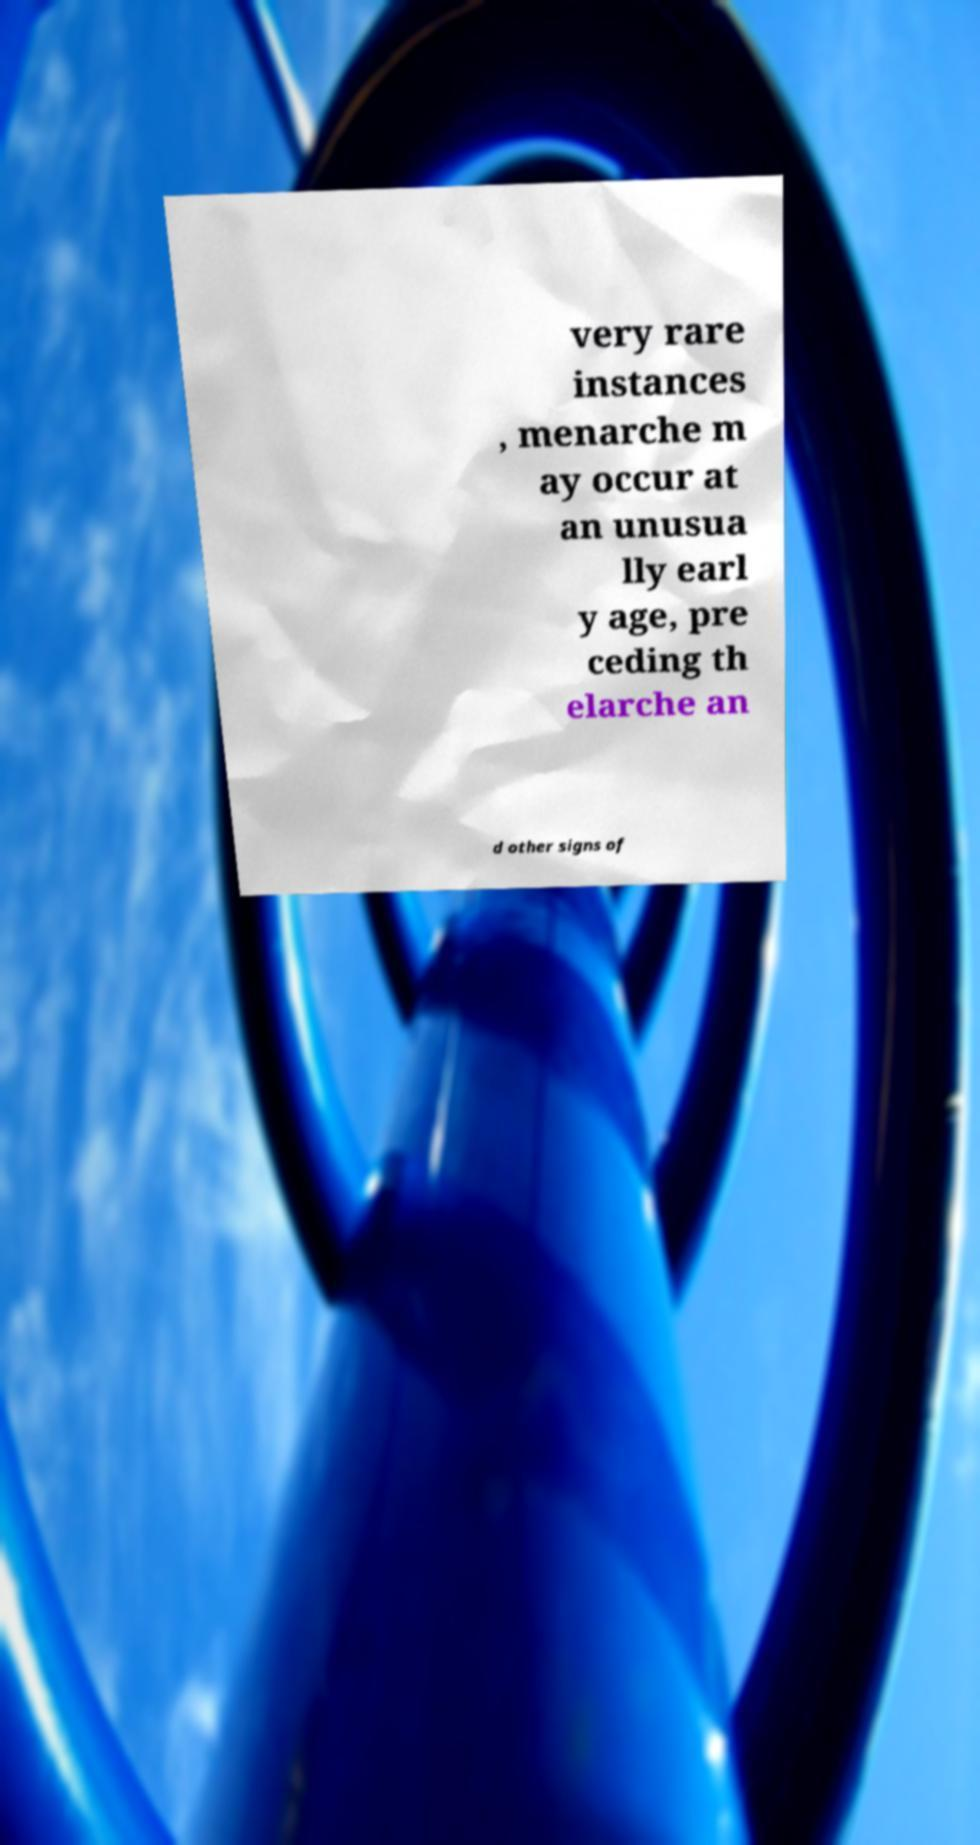For documentation purposes, I need the text within this image transcribed. Could you provide that? very rare instances , menarche m ay occur at an unusua lly earl y age, pre ceding th elarche an d other signs of 